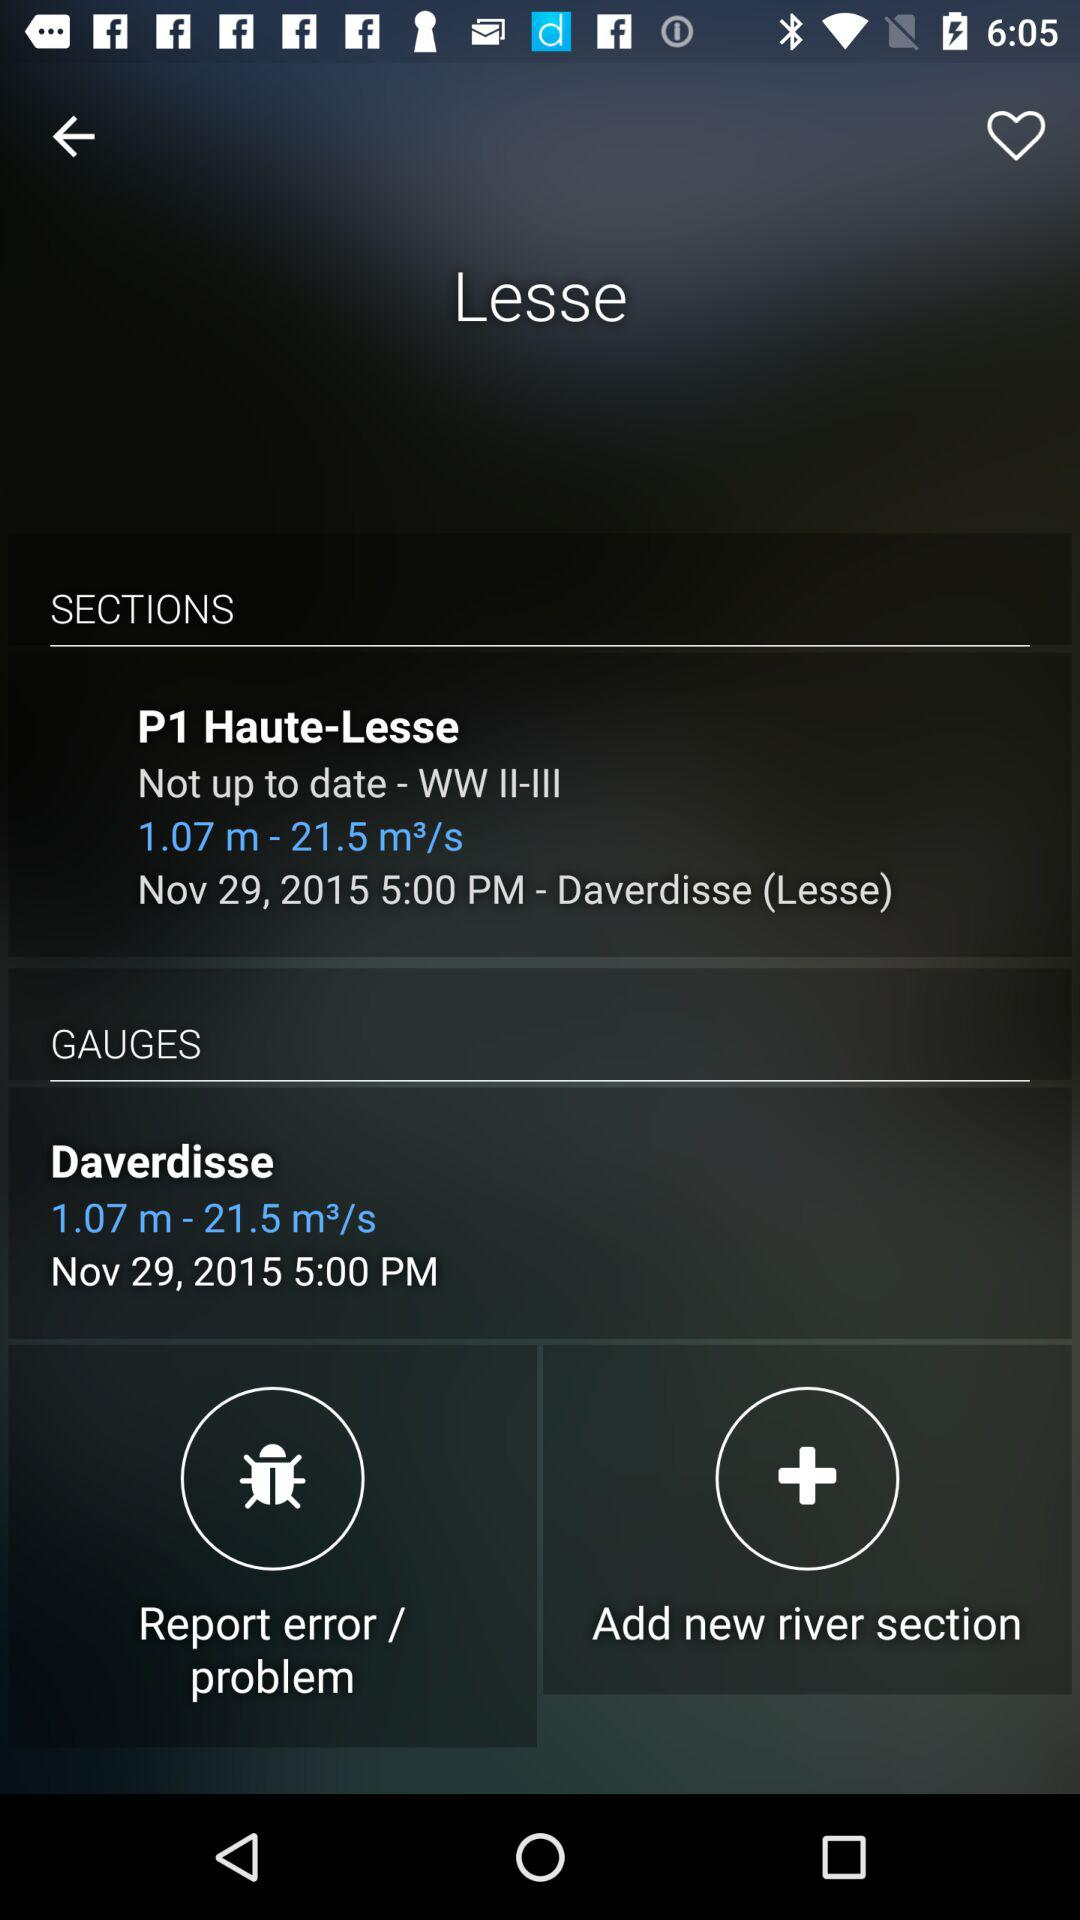At what time has "Daverdisse" been updated? "Daverdisse" has been updated at 5:00 PM. 